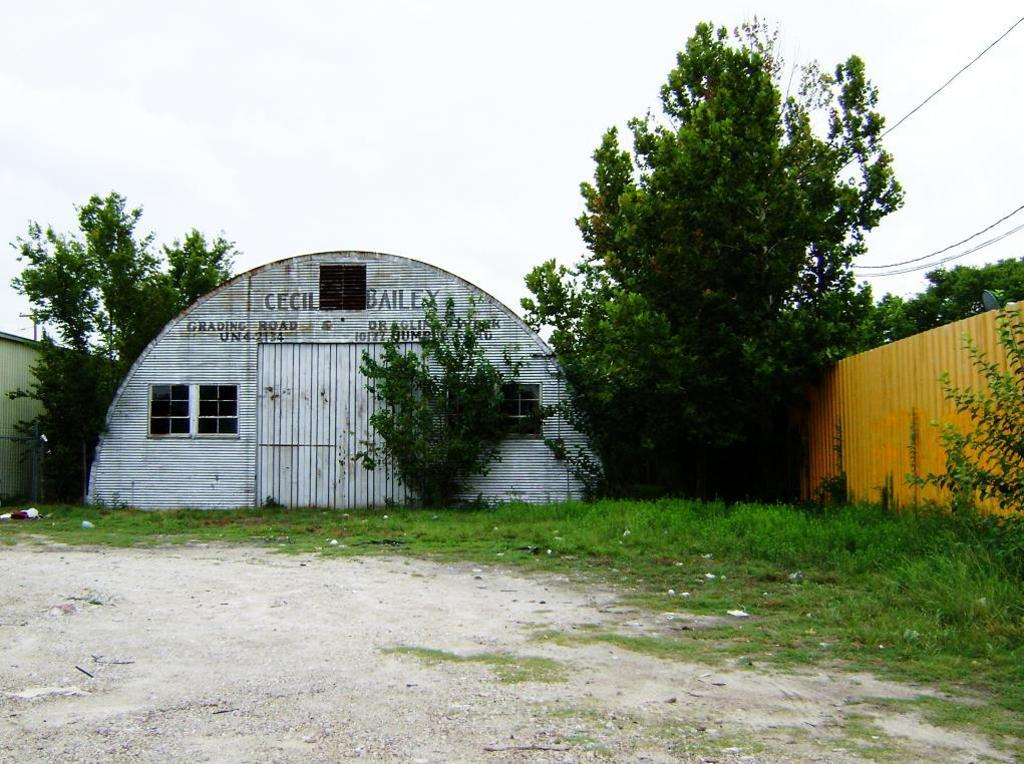What can be seen in the foreground of the picture? In the foreground of the picture, there are plants, grass, and soil. What is located in the center of the picture? In the center of the picture, there are trees, sheds, a grass wall, and cables. How would you describe the sky in the picture? The sky in the picture is cloudy. Can you tell me how many people are shopping in the picture? There are no people or shops present in the image. What type of cable is being pulled by the person in the picture? There is no person or cable being pulled in the image. 